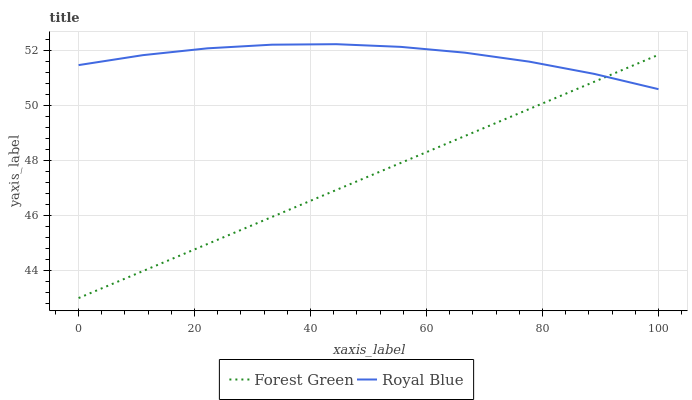Does Forest Green have the minimum area under the curve?
Answer yes or no. Yes. Does Royal Blue have the maximum area under the curve?
Answer yes or no. Yes. Does Forest Green have the maximum area under the curve?
Answer yes or no. No. Is Forest Green the smoothest?
Answer yes or no. Yes. Is Royal Blue the roughest?
Answer yes or no. Yes. Is Forest Green the roughest?
Answer yes or no. No. Does Royal Blue have the highest value?
Answer yes or no. Yes. Does Forest Green have the highest value?
Answer yes or no. No. Does Royal Blue intersect Forest Green?
Answer yes or no. Yes. Is Royal Blue less than Forest Green?
Answer yes or no. No. Is Royal Blue greater than Forest Green?
Answer yes or no. No. 